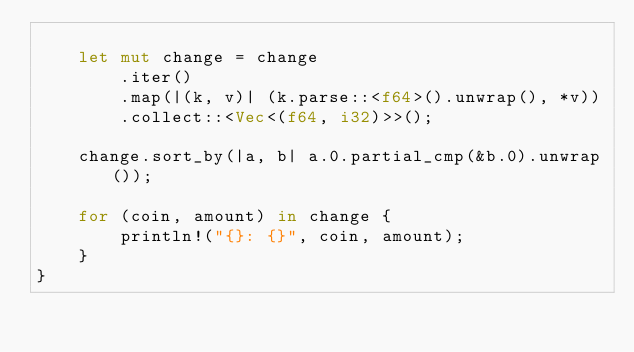<code> <loc_0><loc_0><loc_500><loc_500><_Rust_>
    let mut change = change
        .iter()
        .map(|(k, v)| (k.parse::<f64>().unwrap(), *v))
        .collect::<Vec<(f64, i32)>>();

    change.sort_by(|a, b| a.0.partial_cmp(&b.0).unwrap());

    for (coin, amount) in change {
        println!("{}: {}", coin, amount);
    }
}
</code> 